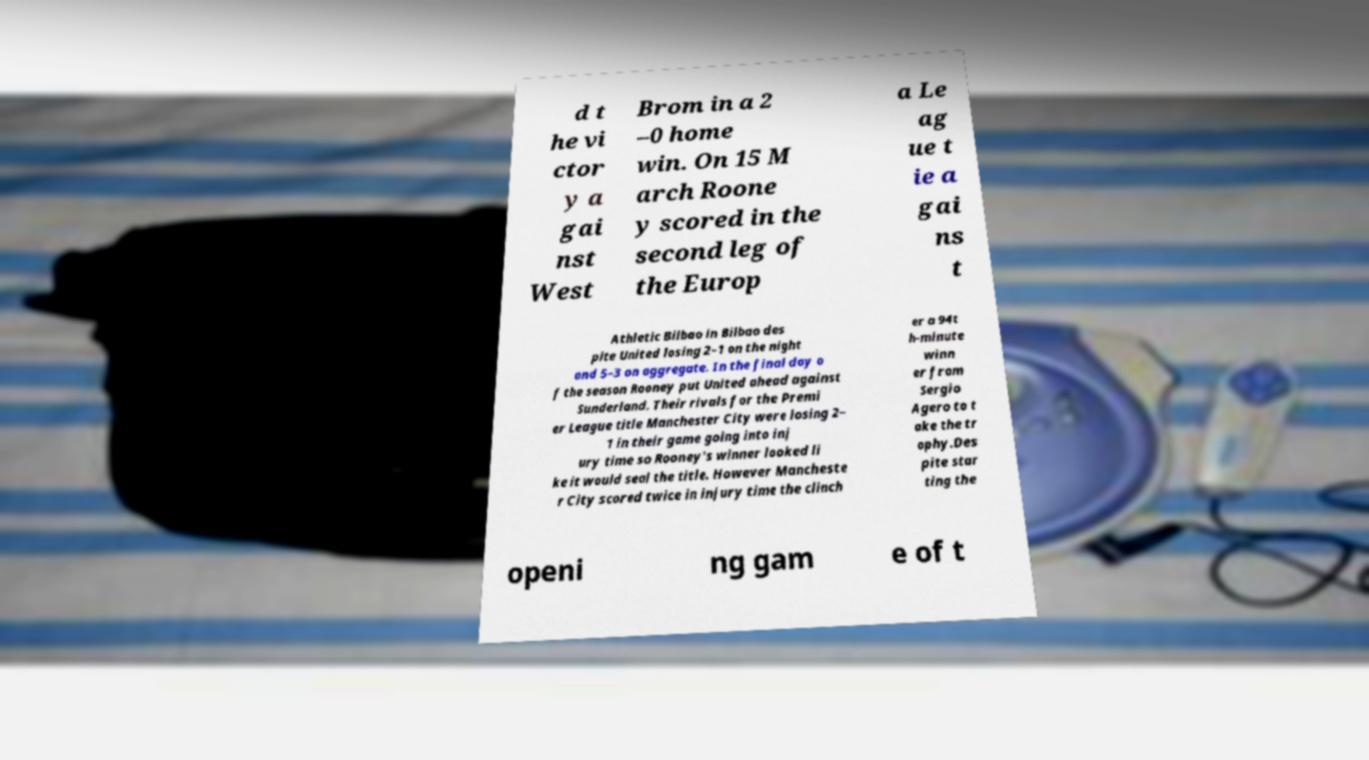Could you extract and type out the text from this image? d t he vi ctor y a gai nst West Brom in a 2 –0 home win. On 15 M arch Roone y scored in the second leg of the Europ a Le ag ue t ie a gai ns t Athletic Bilbao in Bilbao des pite United losing 2–1 on the night and 5–3 on aggregate. In the final day o f the season Rooney put United ahead against Sunderland. Their rivals for the Premi er League title Manchester City were losing 2– 1 in their game going into inj ury time so Rooney's winner looked li ke it would seal the title. However Mancheste r City scored twice in injury time the clinch er a 94t h-minute winn er from Sergio Agero to t ake the tr ophy.Des pite star ting the openi ng gam e of t 